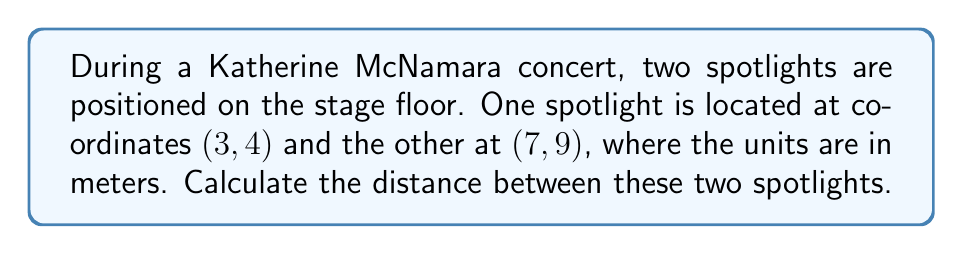Give your solution to this math problem. To find the distance between two points on a plane, we can use the distance formula, which is derived from the Pythagorean theorem:

$$d = \sqrt{(x_2 - x_1)^2 + (y_2 - y_1)^2}$$

Where $(x_1, y_1)$ is the first point and $(x_2, y_2)$ is the second point.

Let's plug in our values:
$(x_1, y_1) = (3, 4)$ and $(x_2, y_2) = (7, 9)$

Step 1: Calculate the differences:
$x_2 - x_1 = 7 - 3 = 4$
$y_2 - y_1 = 9 - 4 = 5$

Step 2: Square these differences:
$(x_2 - x_1)^2 = 4^2 = 16$
$(y_2 - y_1)^2 = 5^2 = 25$

Step 3: Add the squared differences:
$16 + 25 = 41$

Step 4: Take the square root of the sum:
$d = \sqrt{41}$

Step 5: Simplify if possible (in this case, it can't be simplified further)

Therefore, the distance between the two spotlights is $\sqrt{41}$ meters.

[asy]
unitsize(20);
dot((3,4));
dot((7,9));
draw((3,4)--(7,9),red);
label("(3,4)",(3,4),SW);
label("(7,9)",(7,9),NE);
label("$\sqrt{41}$ m",(5,6.5),SE);
[/asy]
Answer: $\sqrt{41}$ meters 